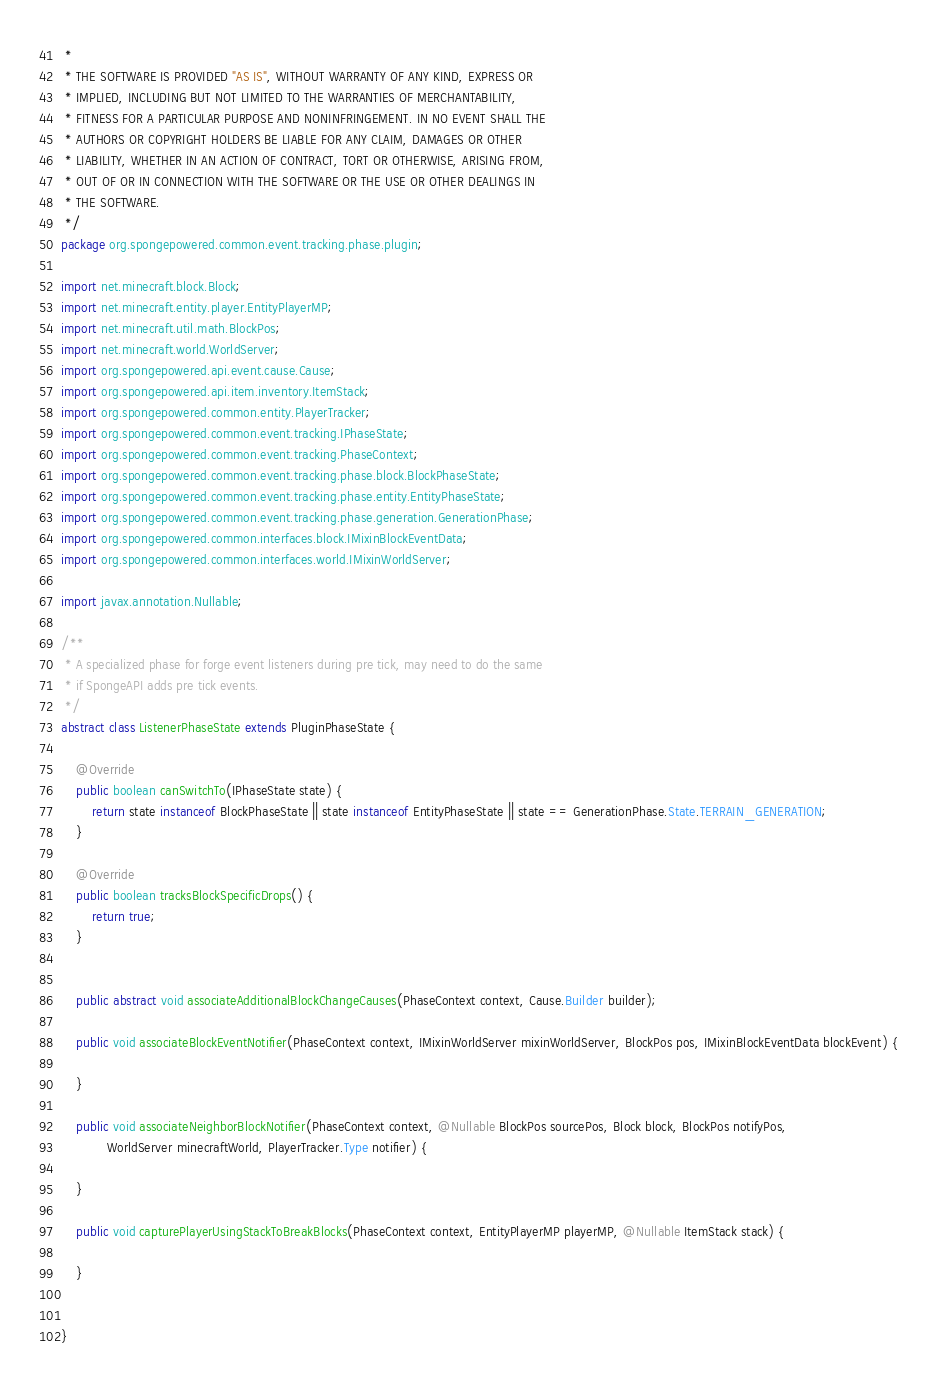Convert code to text. <code><loc_0><loc_0><loc_500><loc_500><_Java_> *
 * THE SOFTWARE IS PROVIDED "AS IS", WITHOUT WARRANTY OF ANY KIND, EXPRESS OR
 * IMPLIED, INCLUDING BUT NOT LIMITED TO THE WARRANTIES OF MERCHANTABILITY,
 * FITNESS FOR A PARTICULAR PURPOSE AND NONINFRINGEMENT. IN NO EVENT SHALL THE
 * AUTHORS OR COPYRIGHT HOLDERS BE LIABLE FOR ANY CLAIM, DAMAGES OR OTHER
 * LIABILITY, WHETHER IN AN ACTION OF CONTRACT, TORT OR OTHERWISE, ARISING FROM,
 * OUT OF OR IN CONNECTION WITH THE SOFTWARE OR THE USE OR OTHER DEALINGS IN
 * THE SOFTWARE.
 */
package org.spongepowered.common.event.tracking.phase.plugin;

import net.minecraft.block.Block;
import net.minecraft.entity.player.EntityPlayerMP;
import net.minecraft.util.math.BlockPos;
import net.minecraft.world.WorldServer;
import org.spongepowered.api.event.cause.Cause;
import org.spongepowered.api.item.inventory.ItemStack;
import org.spongepowered.common.entity.PlayerTracker;
import org.spongepowered.common.event.tracking.IPhaseState;
import org.spongepowered.common.event.tracking.PhaseContext;
import org.spongepowered.common.event.tracking.phase.block.BlockPhaseState;
import org.spongepowered.common.event.tracking.phase.entity.EntityPhaseState;
import org.spongepowered.common.event.tracking.phase.generation.GenerationPhase;
import org.spongepowered.common.interfaces.block.IMixinBlockEventData;
import org.spongepowered.common.interfaces.world.IMixinWorldServer;

import javax.annotation.Nullable;

/**
 * A specialized phase for forge event listeners during pre tick, may need to do the same
 * if SpongeAPI adds pre tick events.
 */
abstract class ListenerPhaseState extends PluginPhaseState {

    @Override
    public boolean canSwitchTo(IPhaseState state) {
        return state instanceof BlockPhaseState || state instanceof EntityPhaseState || state == GenerationPhase.State.TERRAIN_GENERATION;
    }

    @Override
    public boolean tracksBlockSpecificDrops() {
        return true;
    }


    public abstract void associateAdditionalBlockChangeCauses(PhaseContext context, Cause.Builder builder);

    public void associateBlockEventNotifier(PhaseContext context, IMixinWorldServer mixinWorldServer, BlockPos pos, IMixinBlockEventData blockEvent) {

    }

    public void associateNeighborBlockNotifier(PhaseContext context, @Nullable BlockPos sourcePos, Block block, BlockPos notifyPos,
            WorldServer minecraftWorld, PlayerTracker.Type notifier) {

    }

    public void capturePlayerUsingStackToBreakBlocks(PhaseContext context, EntityPlayerMP playerMP, @Nullable ItemStack stack) {

    }


}
</code> 